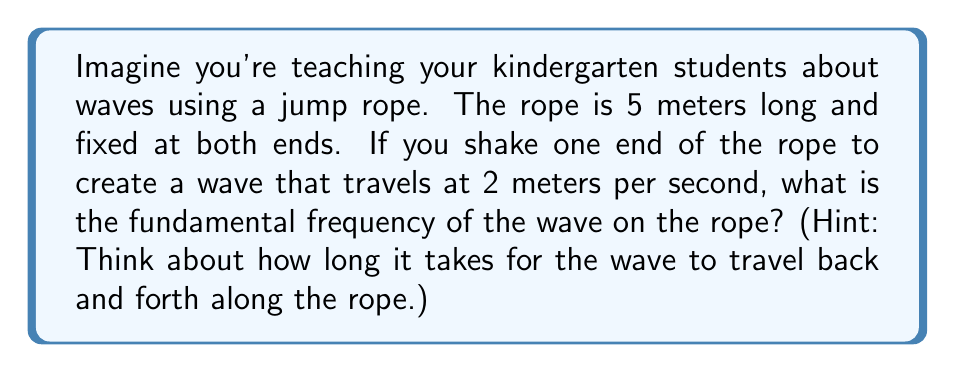Could you help me with this problem? To solve this problem, we need to use the wave equation for a vibrating string. The fundamental frequency is the lowest frequency at which the string vibrates in a standing wave pattern. Let's break this down step-by-step:

1) The wave equation for a vibrating string is:

   $$ \frac{\partial^2 u}{\partial t^2} = c^2 \frac{\partial^2 u}{\partial x^2} $$

   where $u$ is the displacement, $t$ is time, $x$ is position, and $c$ is the wave speed.

2) For a string fixed at both ends, the fundamental mode has nodes at both ends and one antinode in the middle. This forms half a wavelength.

3) The length of the rope ($L$) is 5 meters, so:

   $$ L = \frac{1}{2}\lambda $$
   $$ 5 = \frac{1}{2}\lambda $$
   $$ \lambda = 10 \text{ meters} $$

4) We know that wave speed ($c$) is related to frequency ($f$) and wavelength ($\lambda$) by:

   $$ c = f\lambda $$

5) Rearranging this equation and plugging in our known values:

   $$ f = \frac{c}{\lambda} = \frac{2 \text{ m/s}}{10 \text{ m}} = 0.2 \text{ Hz} $$

This means the wave completes one full cycle every 5 seconds, which is a concept we can demonstrate with the jump rope!
Answer: The fundamental frequency of the wave on the rope is 0.2 Hz. 